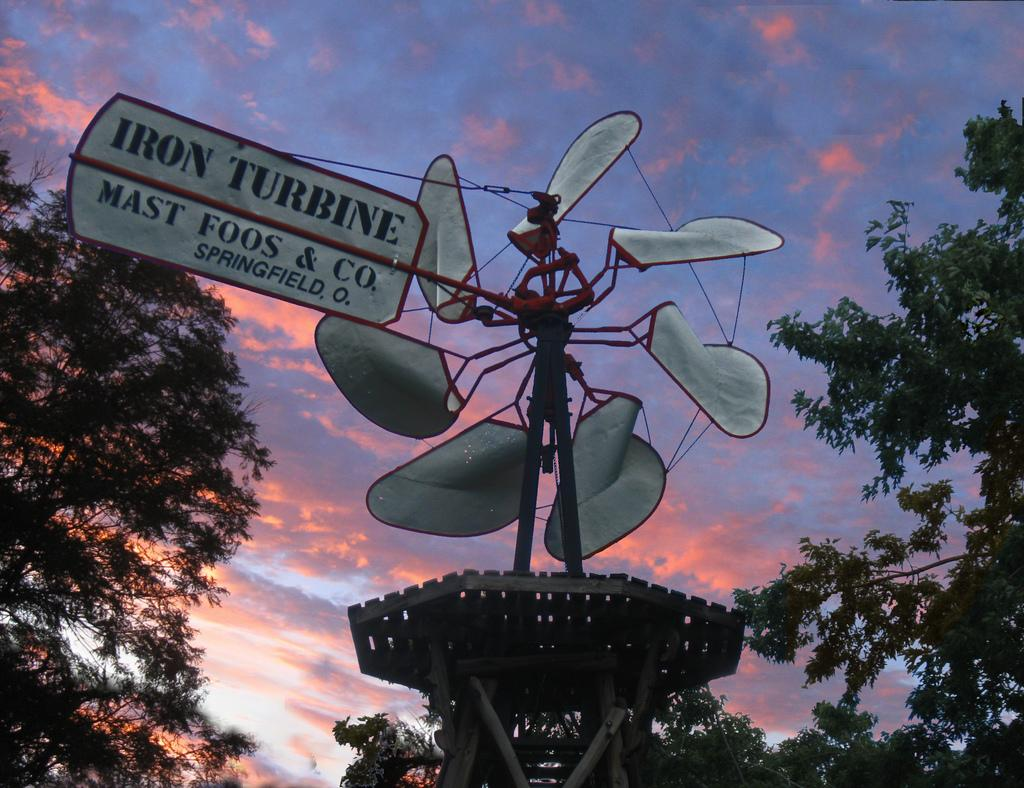What is the main structure in the image? There is a stand with boards in the image. What is on the boards? Something is written on the boards. What type of vegetation is present near the stand? There are trees on the sides of the stand. What can be seen in the background of the image? The sky is visible in the background of the image, and there are clouds in the sky. What type of wine is being served on the stand in the image? There is no wine present in the image; it features a stand with boards and trees on the sides. How many zebras can be seen grazing near the stand in the image? There are no zebras present in the image; it only features a stand with boards, trees, and the sky in the background. 